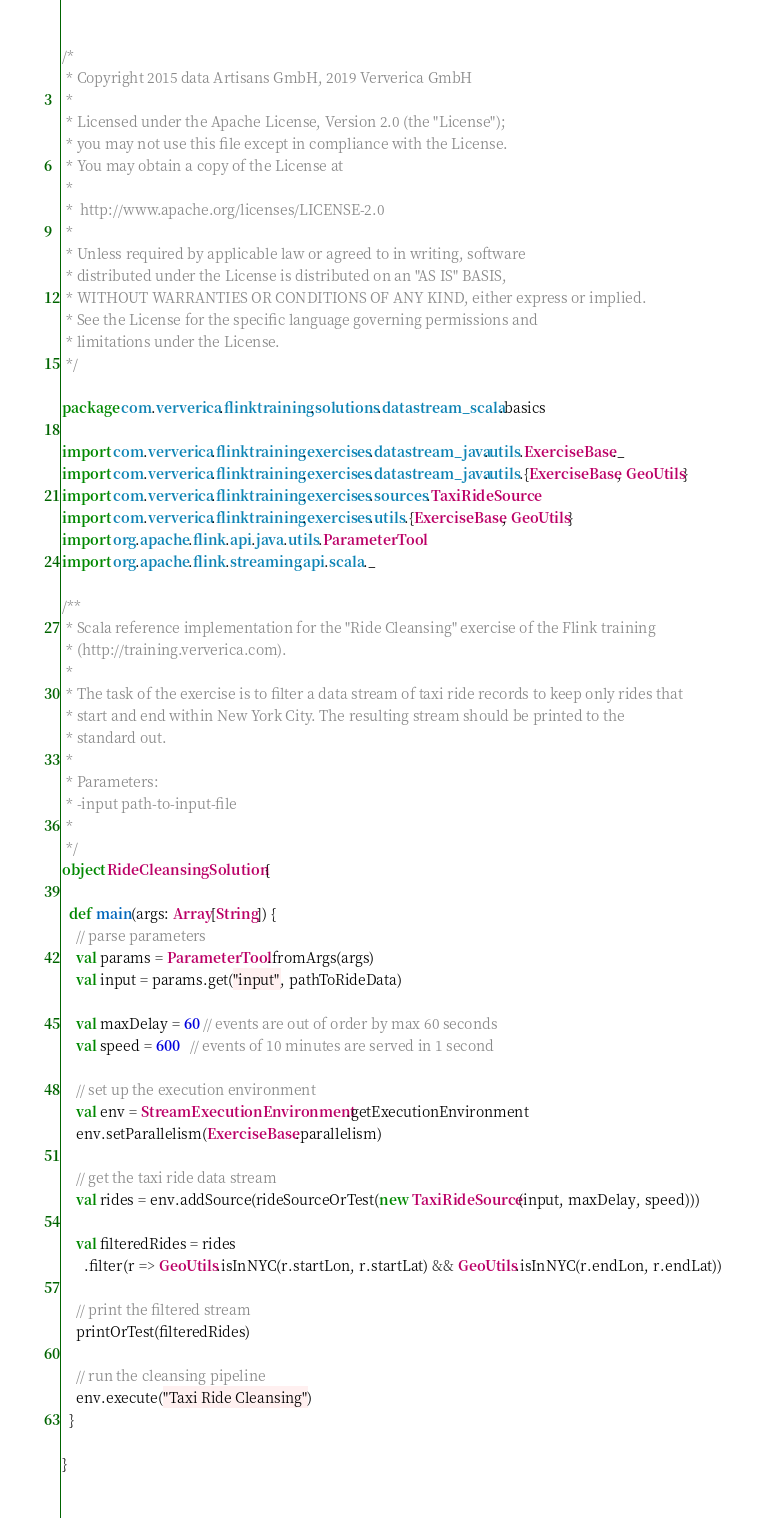<code> <loc_0><loc_0><loc_500><loc_500><_Scala_>/*
 * Copyright 2015 data Artisans GmbH, 2019 Ververica GmbH
 *
 * Licensed under the Apache License, Version 2.0 (the "License");
 * you may not use this file except in compliance with the License.
 * You may obtain a copy of the License at
 *
 *  http://www.apache.org/licenses/LICENSE-2.0
 *
 * Unless required by applicable law or agreed to in writing, software
 * distributed under the License is distributed on an "AS IS" BASIS,
 * WITHOUT WARRANTIES OR CONDITIONS OF ANY KIND, either express or implied.
 * See the License for the specific language governing permissions and
 * limitations under the License.
 */

package com.ververica.flinktraining.solutions.datastream_scala.basics

import com.ververica.flinktraining.exercises.datastream_java.utils.ExerciseBase._
import com.ververica.flinktraining.exercises.datastream_java.utils.{ExerciseBase, GeoUtils}
import com.ververica.flinktraining.exercises.sources.TaxiRideSource
import com.ververica.flinktraining.exercises.utils.{ExerciseBase, GeoUtils}
import org.apache.flink.api.java.utils.ParameterTool
import org.apache.flink.streaming.api.scala._

/**
 * Scala reference implementation for the "Ride Cleansing" exercise of the Flink training
 * (http://training.ververica.com).
 *
 * The task of the exercise is to filter a data stream of taxi ride records to keep only rides that
 * start and end within New York City. The resulting stream should be printed to the
 * standard out.
 *
 * Parameters:
 * -input path-to-input-file
 *
 */
object RideCleansingSolution {

  def main(args: Array[String]) {
    // parse parameters
    val params = ParameterTool.fromArgs(args)
    val input = params.get("input", pathToRideData)

    val maxDelay = 60 // events are out of order by max 60 seconds
    val speed = 600   // events of 10 minutes are served in 1 second

    // set up the execution environment
    val env = StreamExecutionEnvironment.getExecutionEnvironment
    env.setParallelism(ExerciseBase.parallelism)

    // get the taxi ride data stream
    val rides = env.addSource(rideSourceOrTest(new TaxiRideSource(input, maxDelay, speed)))

    val filteredRides = rides
      .filter(r => GeoUtils.isInNYC(r.startLon, r.startLat) && GeoUtils.isInNYC(r.endLon, r.endLat))

    // print the filtered stream
    printOrTest(filteredRides)

    // run the cleansing pipeline
    env.execute("Taxi Ride Cleansing")
  }

}
</code> 